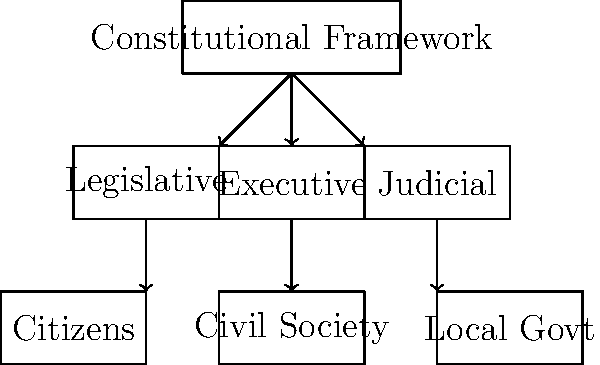Based on the organizational chart provided, which component serves as the overarching framework for the ideal structure of a just society, and how does it relate to the other elements in the system? To answer this question, we need to analyze the hierarchical structure presented in the organizational chart:

1. The topmost element in the chart is labeled "Constitutional Framework." This indicates that it serves as the overarching structure for the entire system.

2. Directly below the Constitutional Framework, we see three branches: Legislative, Executive, and Judicial. These correspond to the classic separation of powers in many democratic systems.

3. The Constitutional Framework has arrows pointing to all three branches, suggesting that it governs and defines the roles and limitations of these branches.

4. Below the three branches, we find Citizens, Civil Society, and Local Government. These represent the grassroots level of the society.

5. Each of the three main branches (Legislative, Executive, and Judicial) has an arrow pointing to one of the grassroots elements, indicating a direct relationship or responsibility.

6. The Constitutional Framework, being at the top, indirectly influences all levels of the society through the three branches it governs.

This structure suggests a system where the Constitutional Framework provides the foundational principles and rules that guide the entire societal structure. It ensures a balance of power between the three branches and ultimately serves the citizens, civil society, and local government.
Answer: Constitutional Framework; it governs all other elements 